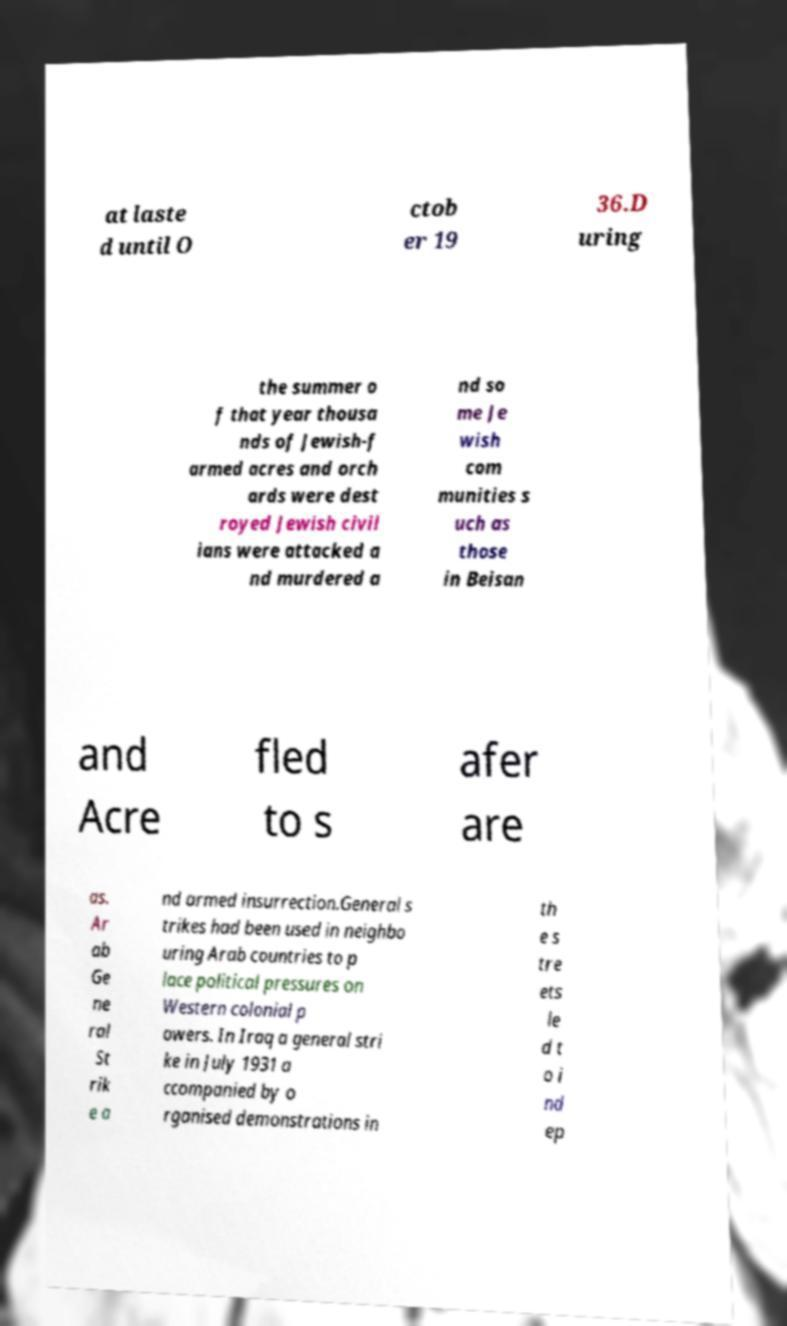Please read and relay the text visible in this image. What does it say? at laste d until O ctob er 19 36.D uring the summer o f that year thousa nds of Jewish-f armed acres and orch ards were dest royed Jewish civil ians were attacked a nd murdered a nd so me Je wish com munities s uch as those in Beisan and Acre fled to s afer are as. Ar ab Ge ne ral St rik e a nd armed insurrection.General s trikes had been used in neighbo uring Arab countries to p lace political pressures on Western colonial p owers. In Iraq a general stri ke in July 1931 a ccompanied by o rganised demonstrations in th e s tre ets le d t o i nd ep 